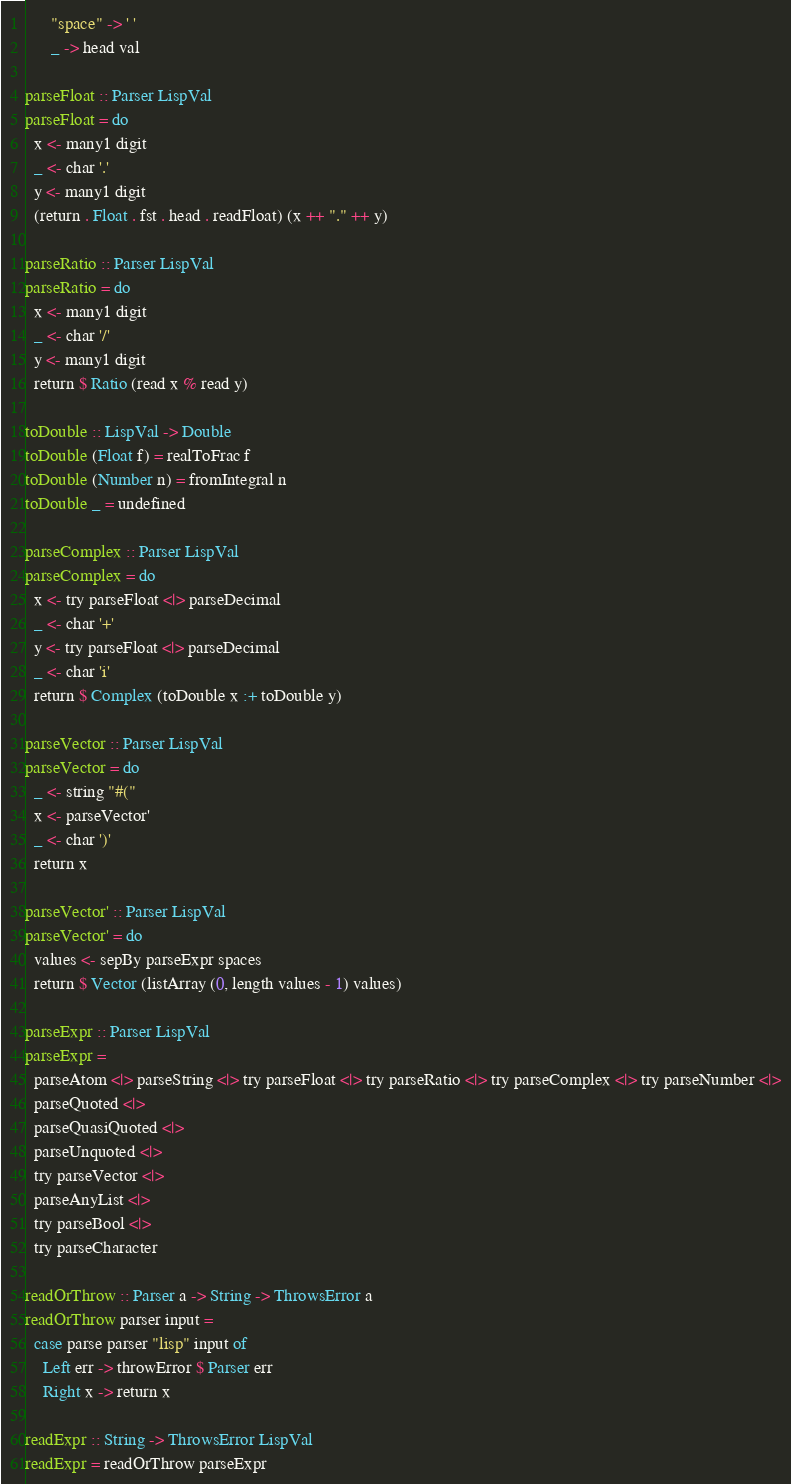<code> <loc_0><loc_0><loc_500><loc_500><_Haskell_>      "space" -> ' '
      _ -> head val

parseFloat :: Parser LispVal
parseFloat = do
  x <- many1 digit
  _ <- char '.'
  y <- many1 digit
  (return . Float . fst . head . readFloat) (x ++ "." ++ y)

parseRatio :: Parser LispVal
parseRatio = do
  x <- many1 digit
  _ <- char '/'
  y <- many1 digit
  return $ Ratio (read x % read y)

toDouble :: LispVal -> Double
toDouble (Float f) = realToFrac f
toDouble (Number n) = fromIntegral n
toDouble _ = undefined

parseComplex :: Parser LispVal
parseComplex = do
  x <- try parseFloat <|> parseDecimal
  _ <- char '+'
  y <- try parseFloat <|> parseDecimal
  _ <- char 'i'
  return $ Complex (toDouble x :+ toDouble y)

parseVector :: Parser LispVal
parseVector = do
  _ <- string "#("
  x <- parseVector'
  _ <- char ')'
  return x

parseVector' :: Parser LispVal
parseVector' = do
  values <- sepBy parseExpr spaces
  return $ Vector (listArray (0, length values - 1) values)

parseExpr :: Parser LispVal
parseExpr =
  parseAtom <|> parseString <|> try parseFloat <|> try parseRatio <|> try parseComplex <|> try parseNumber <|>
  parseQuoted <|>
  parseQuasiQuoted <|>
  parseUnquoted <|>
  try parseVector <|>
  parseAnyList <|>
  try parseBool <|>
  try parseCharacter

readOrThrow :: Parser a -> String -> ThrowsError a
readOrThrow parser input =
  case parse parser "lisp" input of
    Left err -> throwError $ Parser err
    Right x -> return x

readExpr :: String -> ThrowsError LispVal
readExpr = readOrThrow parseExpr
</code> 